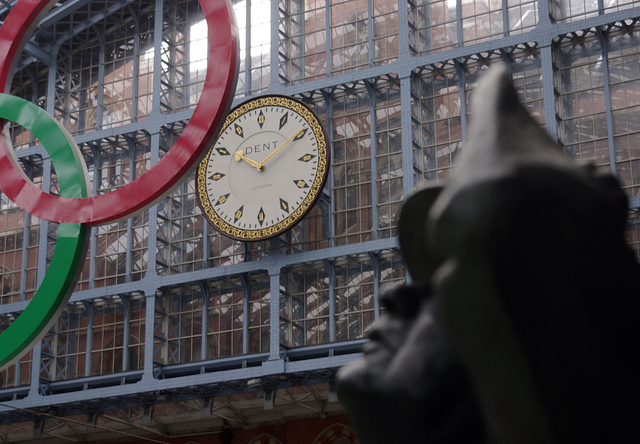Please identify all text content in this image. DENT 